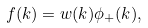<formula> <loc_0><loc_0><loc_500><loc_500>f ( k ) = w ( k ) \phi _ { + } ( k ) ,</formula> 